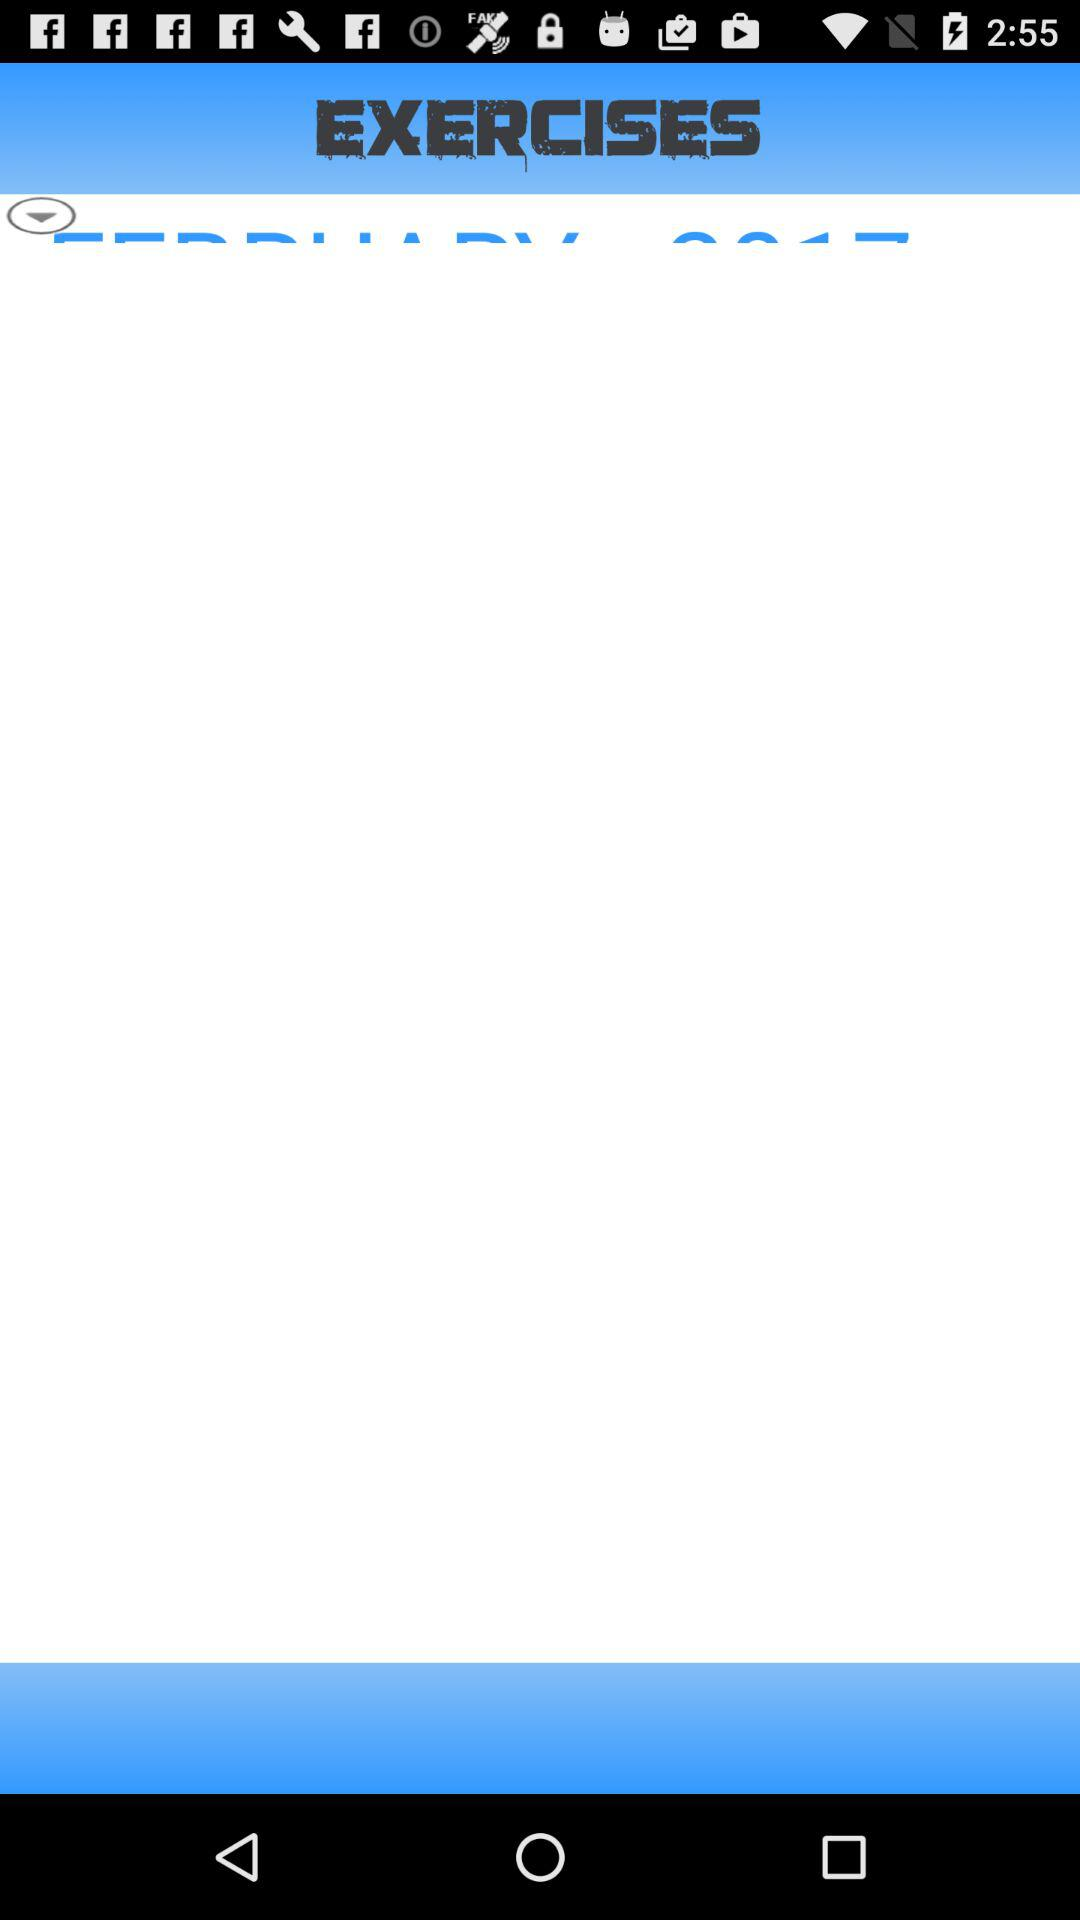What is the application name? The application name is "EXERCISES". 